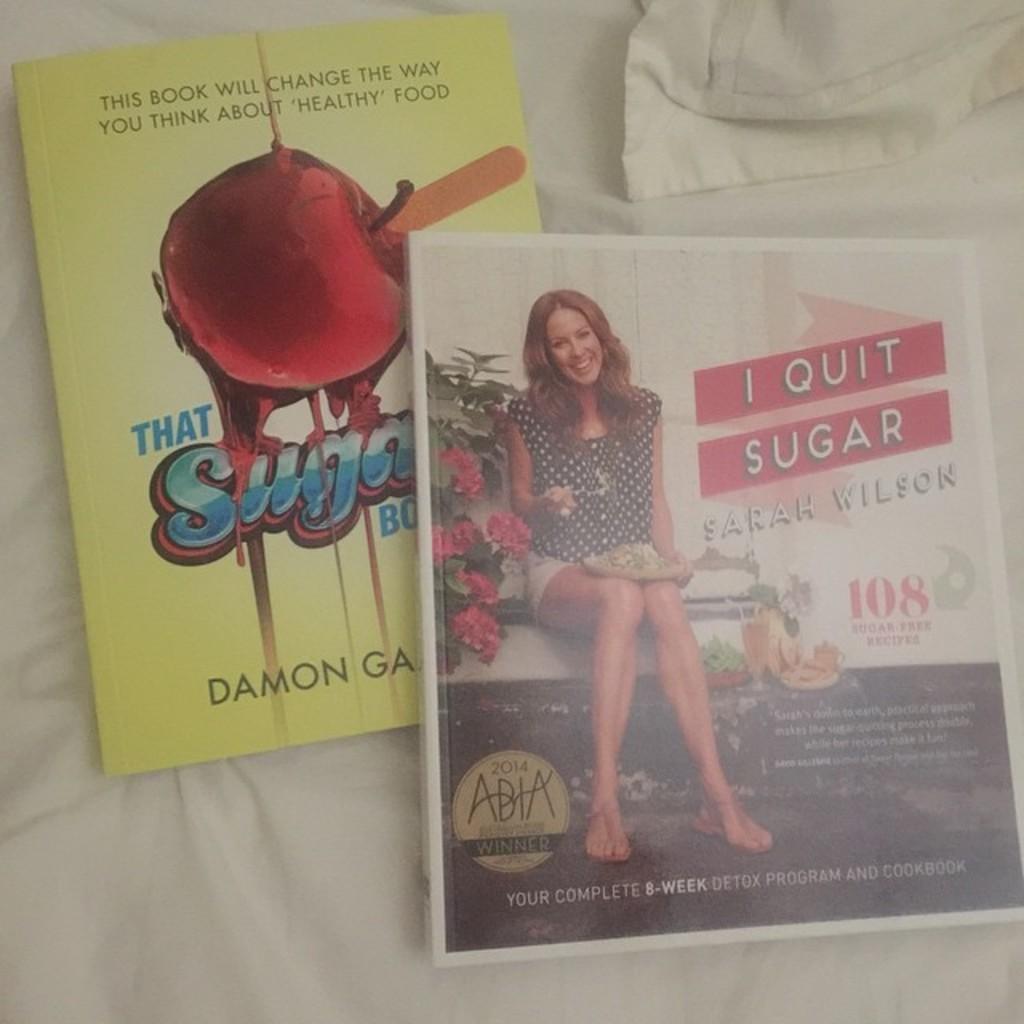Could you give a brief overview of what you see in this image? In this image I can see a white colored cloth and on the cloth I can see two books. 